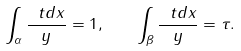<formula> <loc_0><loc_0><loc_500><loc_500>\int _ { \alpha } \frac { \ t d x } { y } = 1 , \quad \int _ { \beta } \frac { \ t d x } { y } = \tau .</formula> 